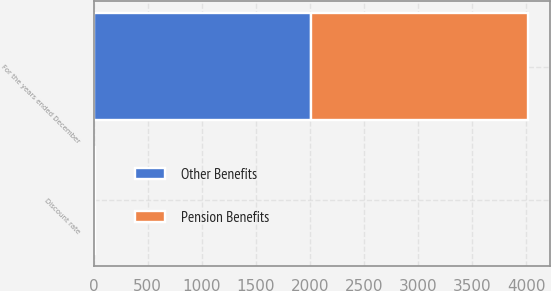Convert chart to OTSL. <chart><loc_0><loc_0><loc_500><loc_500><stacked_bar_chart><ecel><fcel>For the years ended December<fcel>Discount rate<nl><fcel>Other Benefits<fcel>2009<fcel>6.4<nl><fcel>Pension Benefits<fcel>2009<fcel>6.4<nl></chart> 